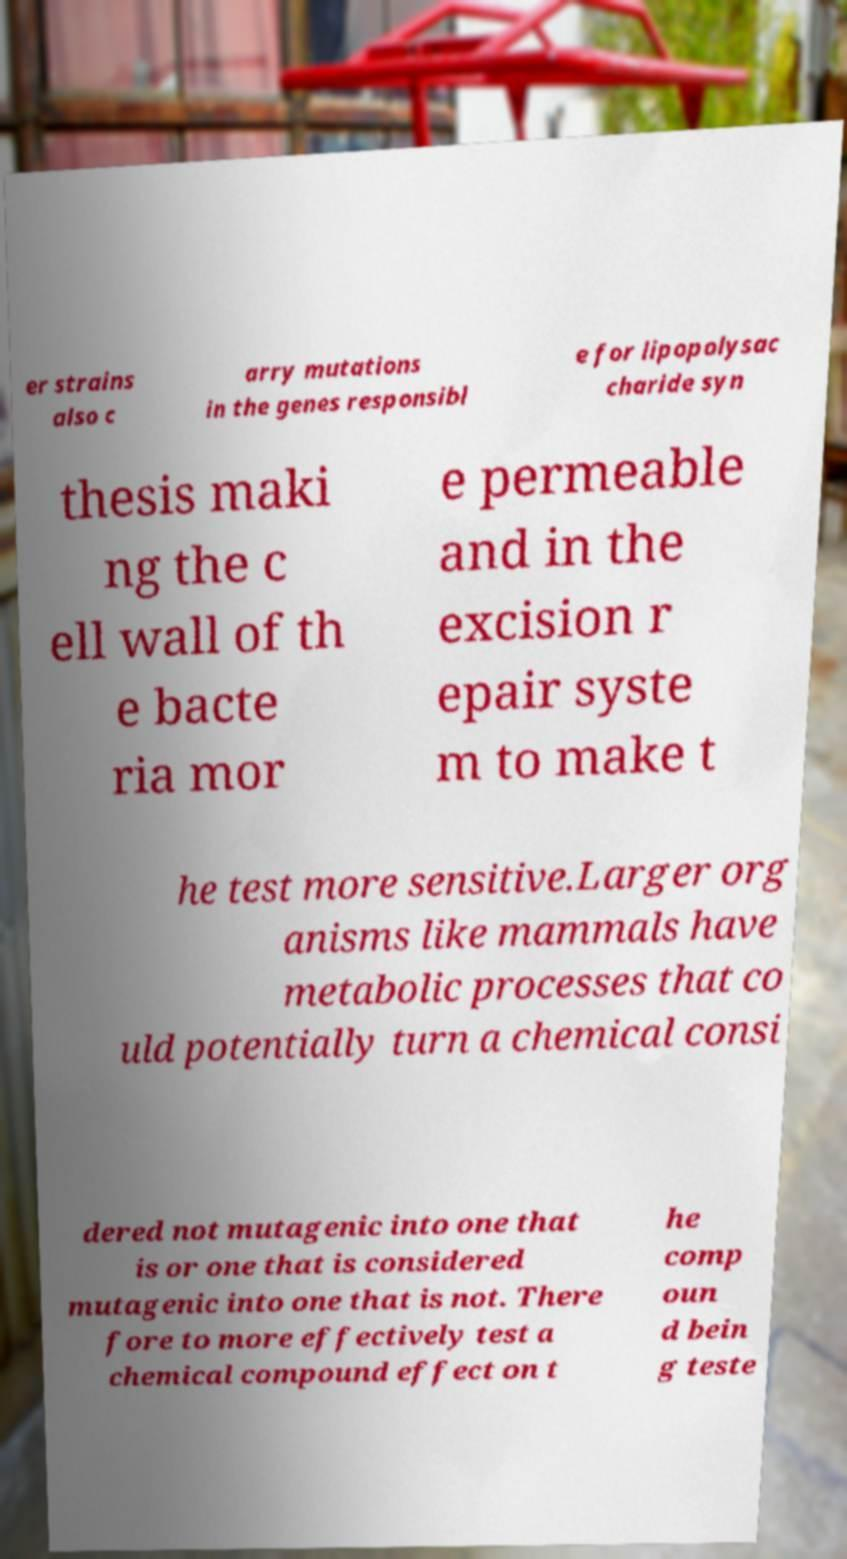Please read and relay the text visible in this image. What does it say? er strains also c arry mutations in the genes responsibl e for lipopolysac charide syn thesis maki ng the c ell wall of th e bacte ria mor e permeable and in the excision r epair syste m to make t he test more sensitive.Larger org anisms like mammals have metabolic processes that co uld potentially turn a chemical consi dered not mutagenic into one that is or one that is considered mutagenic into one that is not. There fore to more effectively test a chemical compound effect on t he comp oun d bein g teste 